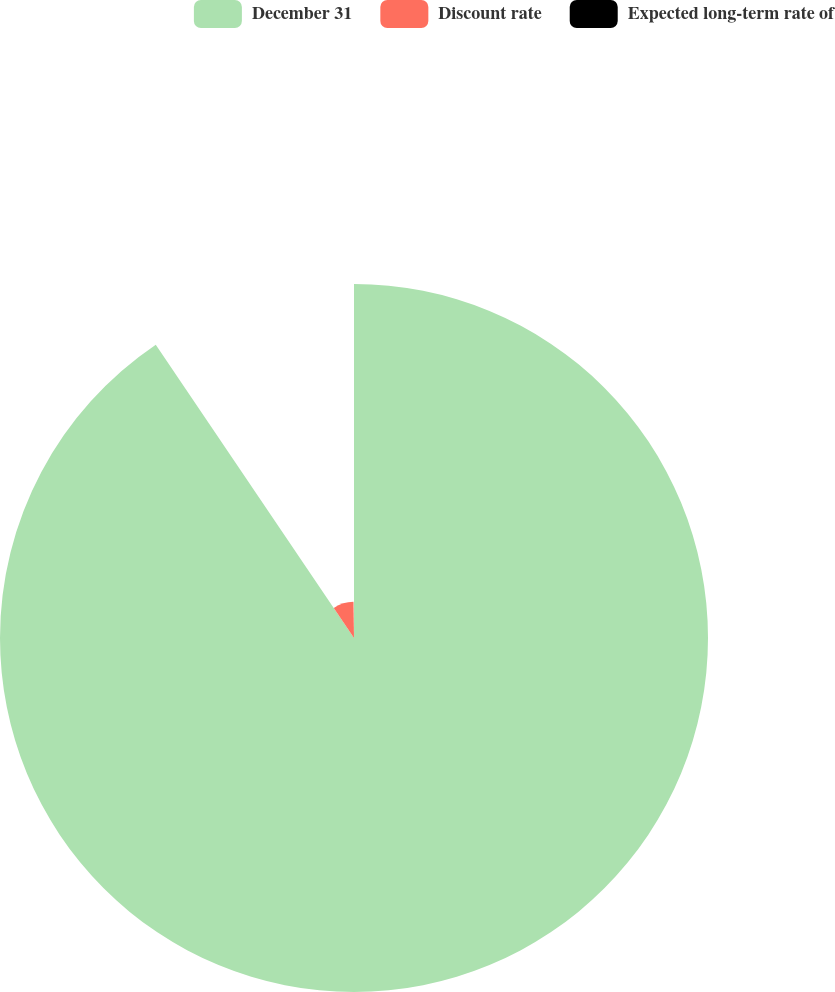<chart> <loc_0><loc_0><loc_500><loc_500><pie_chart><fcel>December 31<fcel>Discount rate<fcel>Expected long-term rate of<nl><fcel>90.54%<fcel>9.25%<fcel>0.21%<nl></chart> 